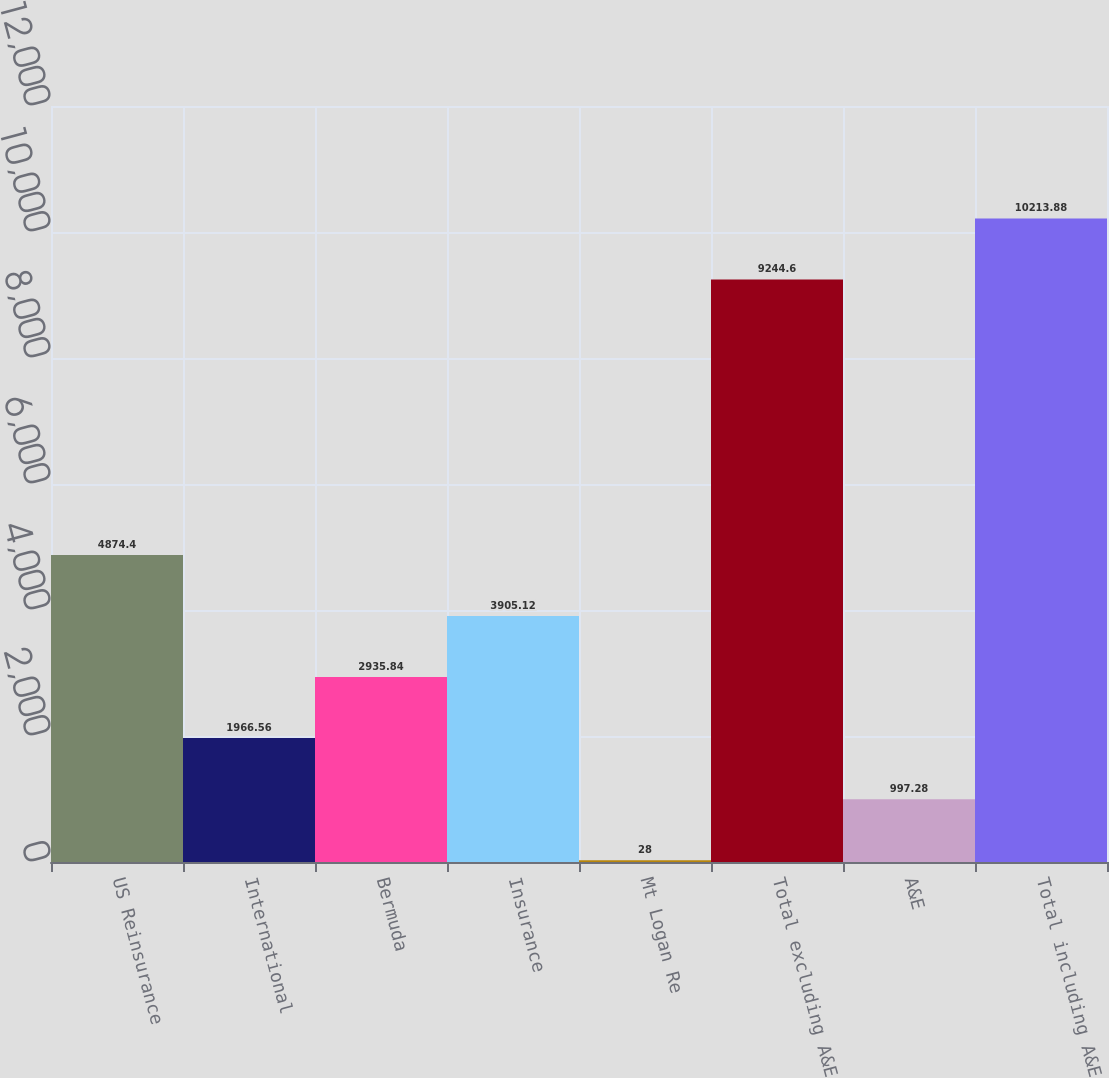Convert chart. <chart><loc_0><loc_0><loc_500><loc_500><bar_chart><fcel>US Reinsurance<fcel>International<fcel>Bermuda<fcel>Insurance<fcel>Mt Logan Re<fcel>Total excluding A&E<fcel>A&E<fcel>Total including A&E<nl><fcel>4874.4<fcel>1966.56<fcel>2935.84<fcel>3905.12<fcel>28<fcel>9244.6<fcel>997.28<fcel>10213.9<nl></chart> 